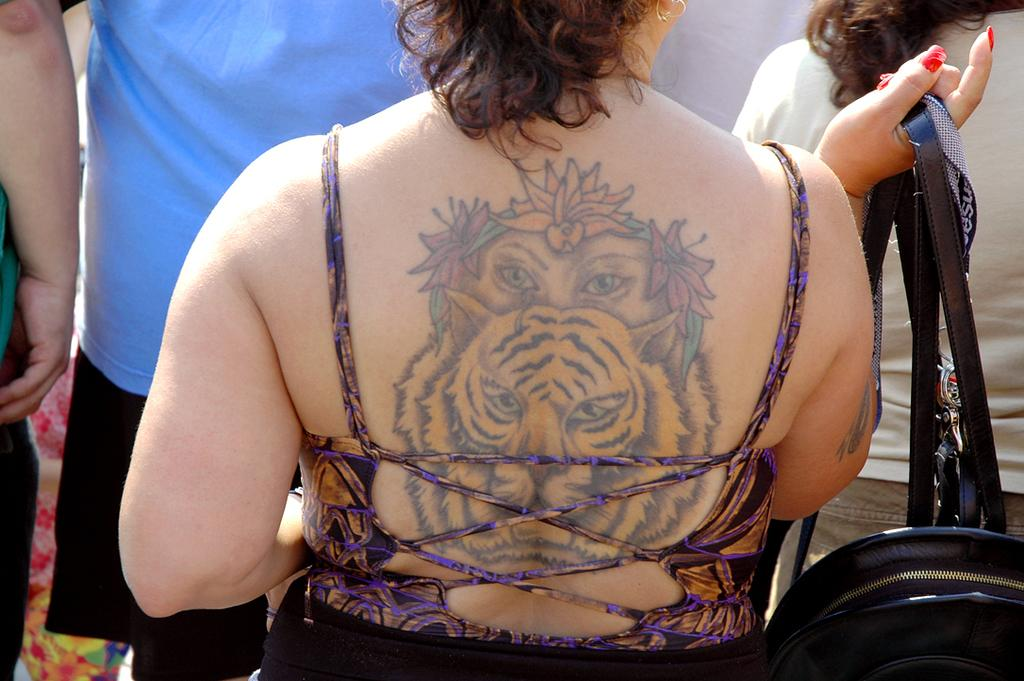Who is the main subject in the image? There is a woman in the image. What is the woman holding in her hand? The woman is holding a bag in her hand. Can you describe any unique features of the woman? The woman has a tattoo on her back. What is the arrangement of people in the image? There are people standing in front of the woman. What event is the woman attending in the image? The provided facts do not mention any specific event, so we cannot determine what event the woman might be attending. 